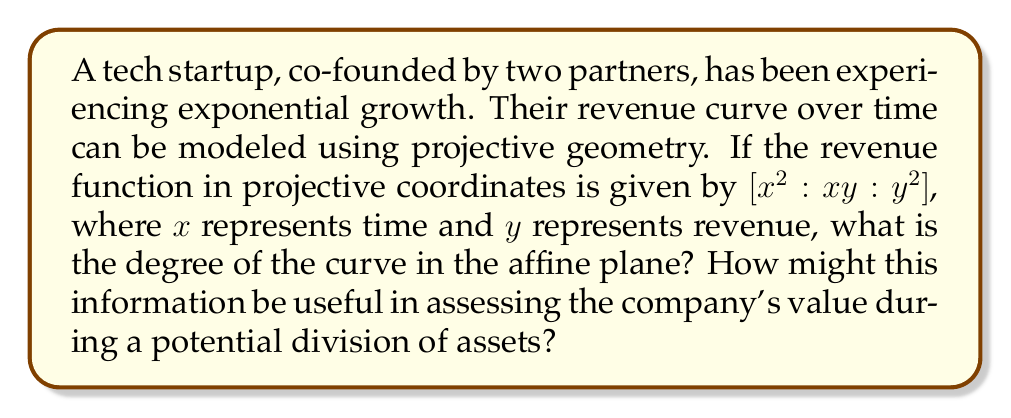Help me with this question. To solve this problem, we'll follow these steps:

1) The given revenue function in projective coordinates is $[x^2 : xy : y^2]$.

2) To convert this to the affine plane, we need to dehomogenize the coordinates. We can do this by setting one of the coordinates to 1. Let's choose the second coordinate:

   $[x^2 : xy : y^2] = [\frac{x^2}{xy} : 1 : \frac{y^2}{xy}] = [\frac{x}{y} : 1 : \frac{y}{x}]$

3) Now, let $u = \frac{x}{y}$. Then the affine equation becomes:

   $[u : 1 : \frac{1}{u}]$

4) This can be written as the equation:

   $u \cdot \frac{1}{u} = 1$

5) This is equivalent to:

   $1 = 1$

6) This equation is satisfied by all points $(u, 1)$ in the affine plane. It represents a straight line.

7) The degree of a curve is the highest degree of its equation in the affine plane. In this case, the equation is of degree 0 (as it's just 1 = 1), but it represents a line, which is a degree 1 curve.

For the business partners, understanding that the revenue curve is actually a straight line in the affine plane (despite its quadratic appearance in projective coordinates) could be crucial. It suggests that the company's growth, when viewed appropriately, is linear rather than exponential. This linear growth pattern might affect how the company's future value is projected and how assets are divided in case of a partnership dissolution.
Answer: Degree 1 (line) 